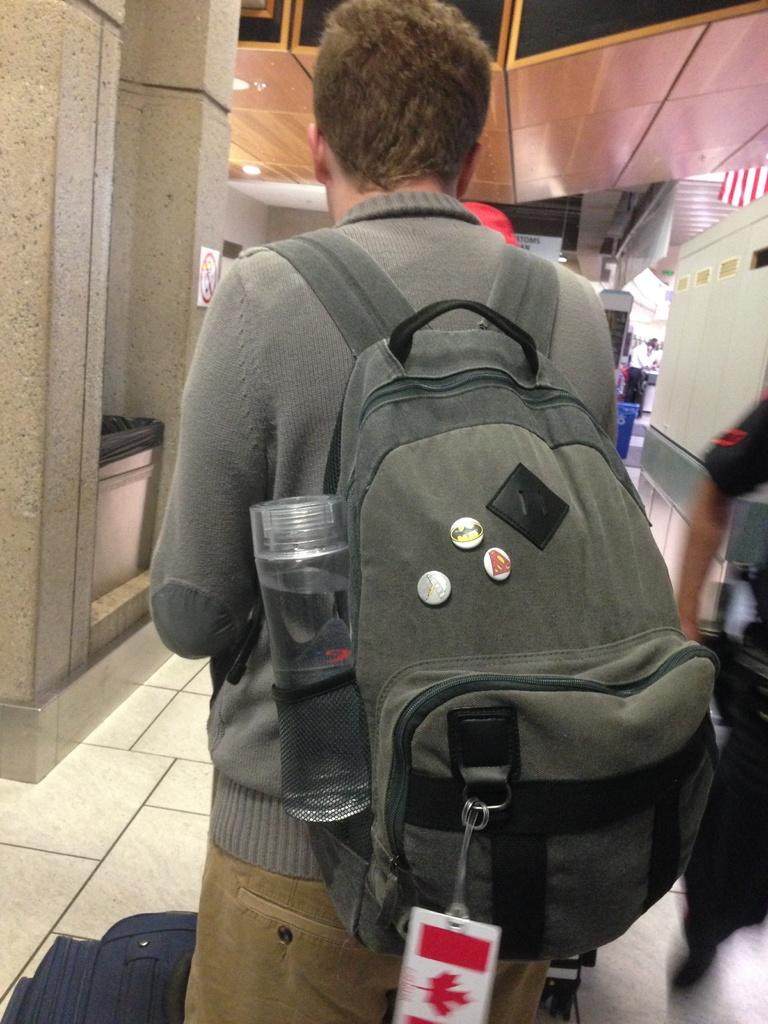What is the main subject of the image? There is a person standing in the image. What is the person wearing? The person is wearing a bag. What can be seen in the background of the image? There is a lift lobby, a dustbin, and a flag in the background of the image. What type of sleet can be seen falling in the image? There is no sleet present in the image. How many toes are visible on the person's foot in the image? The image does not show the person's foot, so the number of toes cannot be determined. 